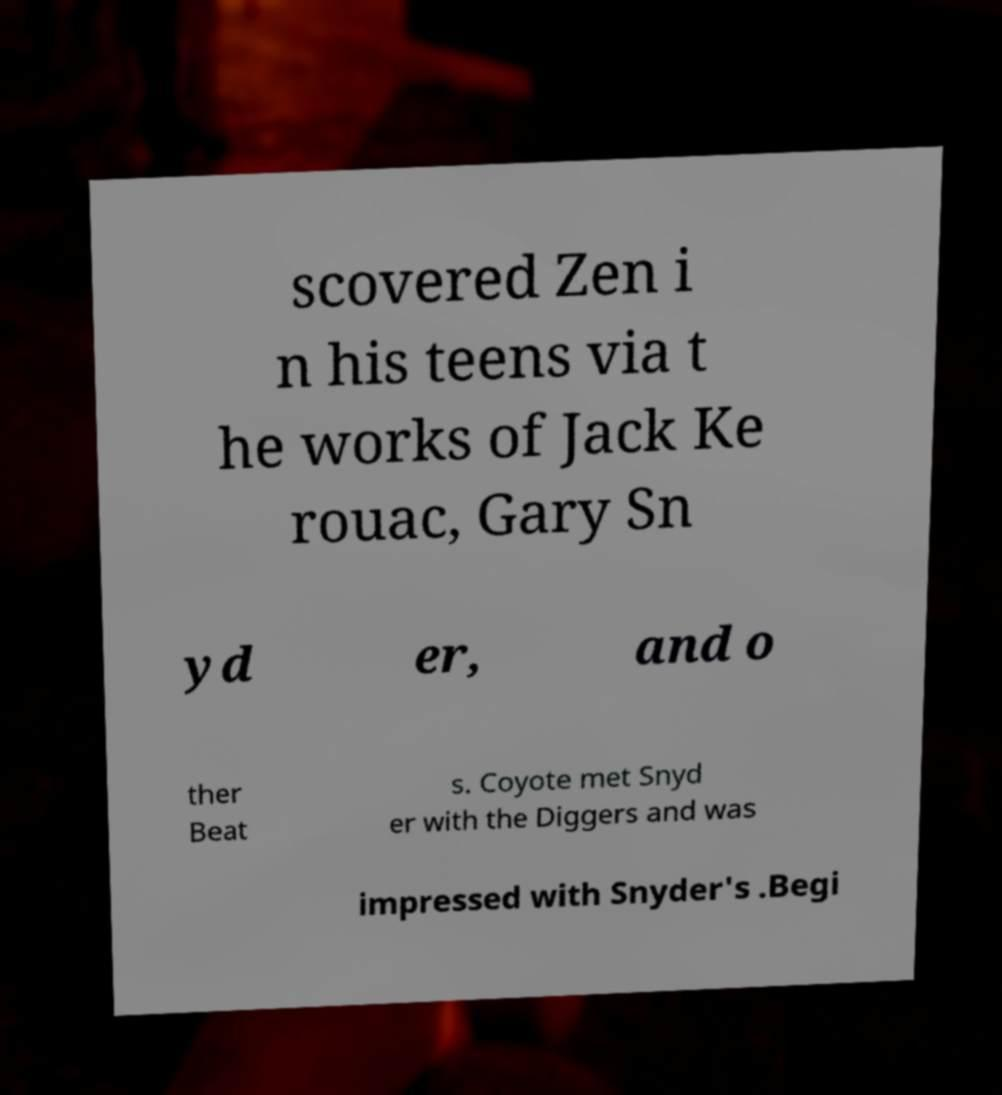I need the written content from this picture converted into text. Can you do that? scovered Zen i n his teens via t he works of Jack Ke rouac, Gary Sn yd er, and o ther Beat s. Coyote met Snyd er with the Diggers and was impressed with Snyder's .Begi 